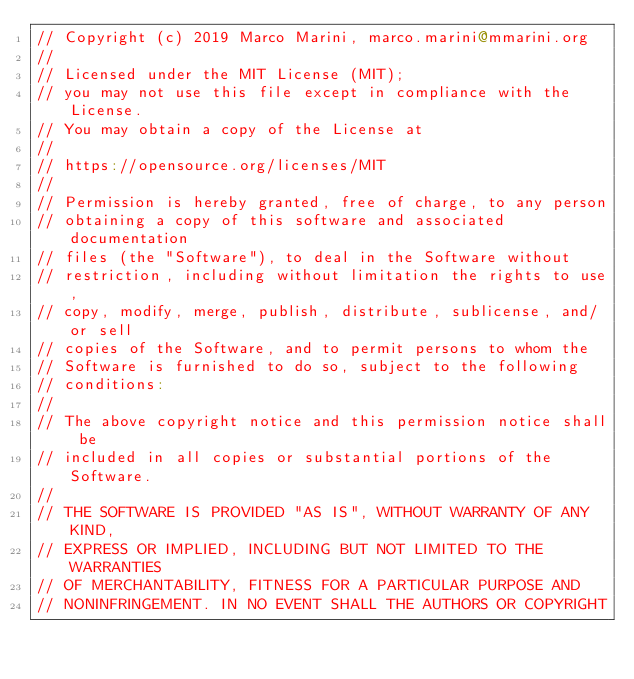<code> <loc_0><loc_0><loc_500><loc_500><_Scala_>// Copyright (c) 2019 Marco Marini, marco.marini@mmarini.org
//
// Licensed under the MIT License (MIT);
// you may not use this file except in compliance with the License.
// You may obtain a copy of the License at
//
// https://opensource.org/licenses/MIT
//
// Permission is hereby granted, free of charge, to any person
// obtaining a copy of this software and associated documentation
// files (the "Software"), to deal in the Software without
// restriction, including without limitation the rights to use,
// copy, modify, merge, publish, distribute, sublicense, and/or sell
// copies of the Software, and to permit persons to whom the
// Software is furnished to do so, subject to the following
// conditions:
//
// The above copyright notice and this permission notice shall be
// included in all copies or substantial portions of the Software.
//
// THE SOFTWARE IS PROVIDED "AS IS", WITHOUT WARRANTY OF ANY KIND,
// EXPRESS OR IMPLIED, INCLUDING BUT NOT LIMITED TO THE WARRANTIES
// OF MERCHANTABILITY, FITNESS FOR A PARTICULAR PURPOSE AND
// NONINFRINGEMENT. IN NO EVENT SHALL THE AUTHORS OR COPYRIGHT</code> 